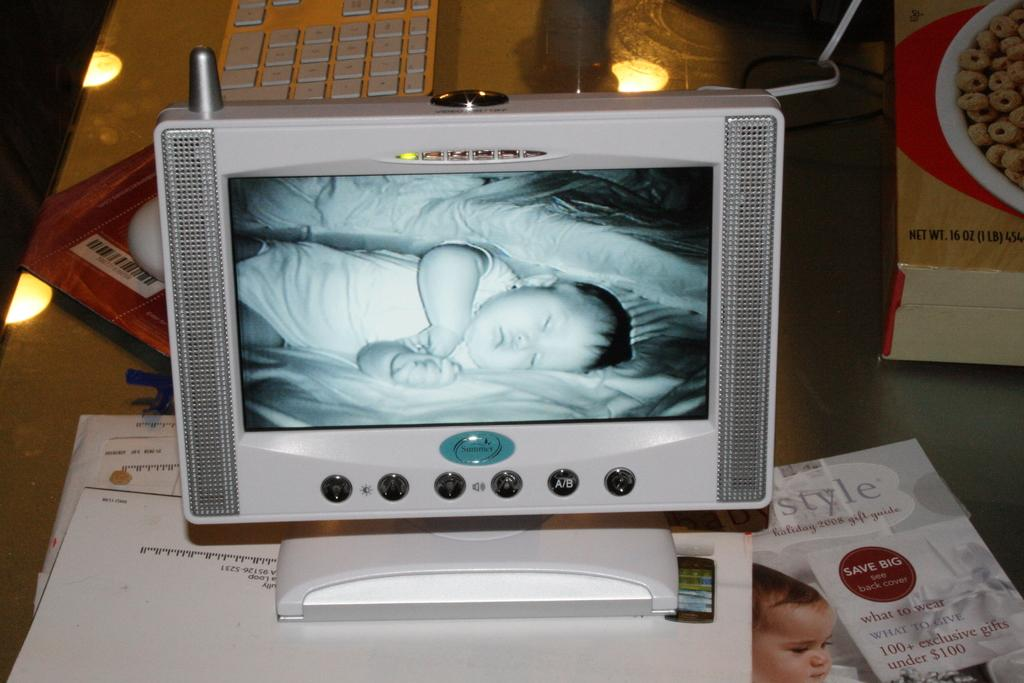<image>
Render a clear and concise summary of the photo. Baby monitor from "Summer" showing a baby sleeping on the screen. 